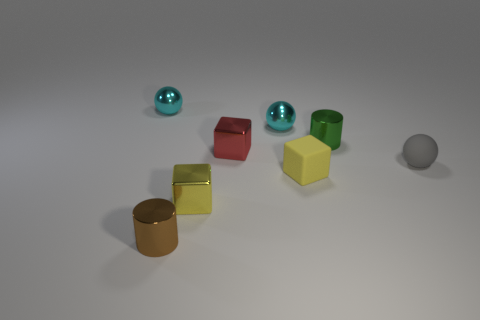There is a ball that is left of the tiny brown metal thing; is it the same color as the tiny metallic ball that is on the right side of the small brown shiny object?
Make the answer very short. Yes. There is a shiny block to the left of the red shiny thing; is there a tiny ball to the right of it?
Make the answer very short. Yes. Is the shape of the tiny matte object on the right side of the green cylinder the same as the shiny object to the left of the brown cylinder?
Provide a short and direct response. Yes. Are the ball to the left of the brown object and the green cylinder behind the tiny red metal block made of the same material?
Your answer should be very brief. Yes. What is the cyan ball right of the tiny metallic thing left of the small brown thing made of?
Offer a terse response. Metal. The cyan thing behind the tiny cyan thing that is right of the brown object on the left side of the small gray sphere is what shape?
Make the answer very short. Sphere. What is the material of the other yellow object that is the same shape as the yellow shiny thing?
Offer a terse response. Rubber. How many small balls are there?
Offer a terse response. 3. What shape is the small cyan metallic object that is right of the tiny yellow shiny cube?
Keep it short and to the point. Sphere. The small metallic ball that is on the left side of the small cyan object that is to the right of the cylinder in front of the small gray sphere is what color?
Keep it short and to the point. Cyan. 